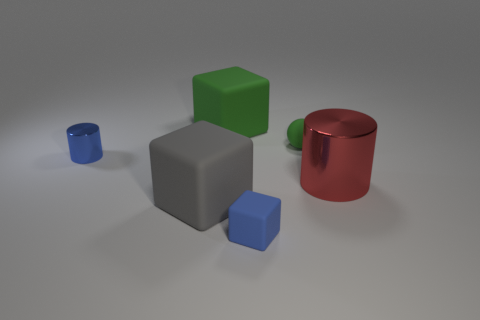Add 3 big gray things. How many objects exist? 9 Subtract all spheres. How many objects are left? 5 Subtract 1 red cylinders. How many objects are left? 5 Subtract all big brown metal cylinders. Subtract all green matte things. How many objects are left? 4 Add 6 small matte objects. How many small matte objects are left? 8 Add 3 tiny red cubes. How many tiny red cubes exist? 3 